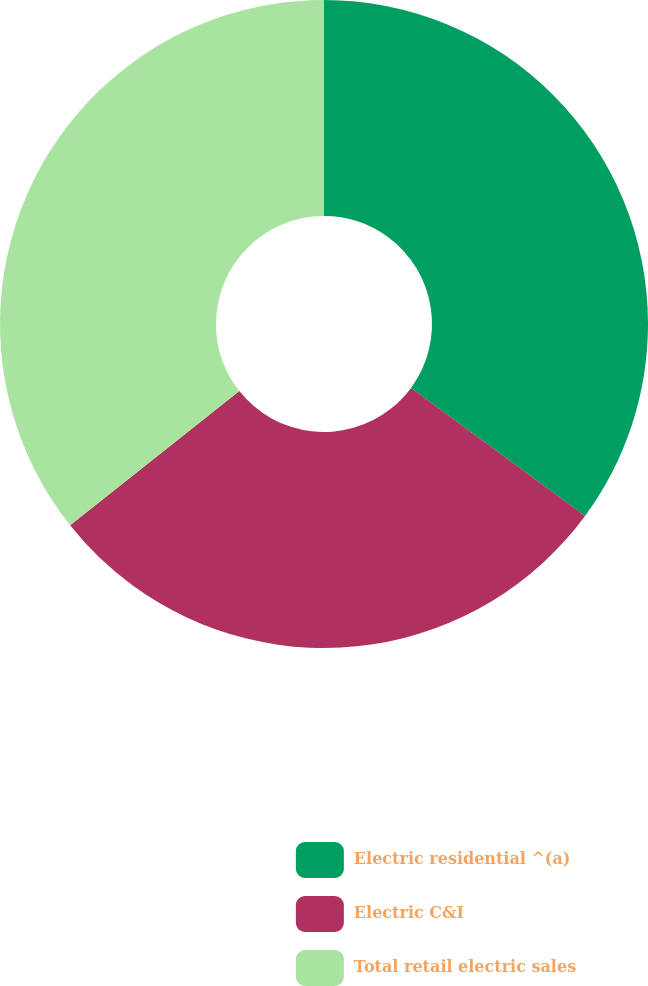Convert chart. <chart><loc_0><loc_0><loc_500><loc_500><pie_chart><fcel>Electric residential ^(a)<fcel>Electric C&I<fcel>Total retail electric sales<nl><fcel>35.09%<fcel>29.24%<fcel>35.67%<nl></chart> 